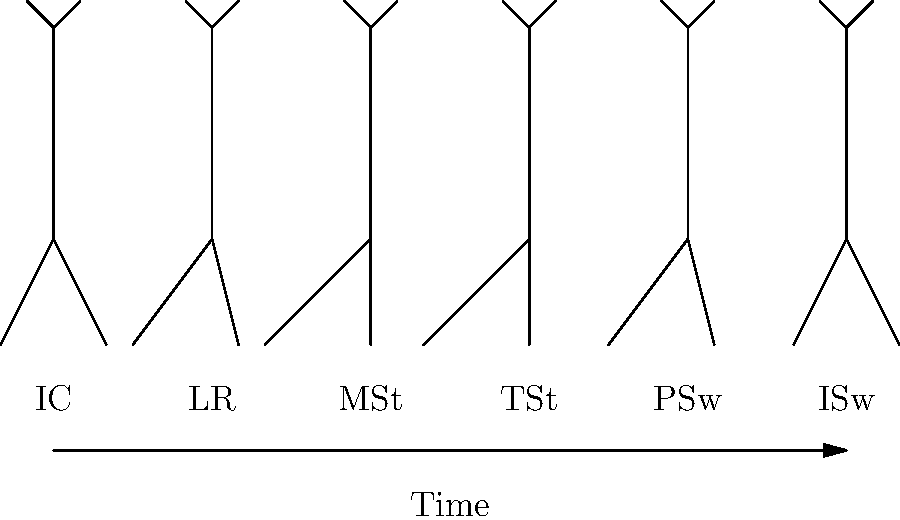As a blockchain entrepreneur familiar with implementing consensus algorithms, consider the gait cycle phases illustrated above. Which phase represents the point where both feet are in contact with the ground, similar to how multiple nodes in a blockchain network validate a transaction simultaneously? To answer this question, let's analyze the gait cycle phases step-by-step:

1. IC (Initial Contact): This is when the heel of the advancing foot touches the ground. Only one foot is in contact with the ground.

2. LR (Loading Response): This phase begins immediately after initial contact and continues until the other foot is lifted for swing. This is the phase where both feet are briefly in contact with the ground.

3. MSt (Mid Stance): The body weight is aligned over the supporting limb. Only one foot is in contact with the ground.

4. TSt (Terminal Stance): The heel rises and the body weight moves ahead of the forefoot. Still only one foot is in contact.

5. PSw (Pre-Swing): This phase begins with initial contact of the opposite limb and ends with ipsilateral toe-off. Again, both feet are briefly in contact with the ground.

6. ISw (Initial Swing): The foot is lifted and the limb moves forward. Only one foot is in contact with the ground.

In the context of blockchain consensus, we're looking for a phase where multiple points of contact (analogous to multiple nodes) are involved simultaneously. This occurs in the Loading Response (LR) phase, where both feet are in contact with the ground, similar to how multiple nodes in a blockchain network might validate a transaction at the same time.
Answer: Loading Response (LR) 